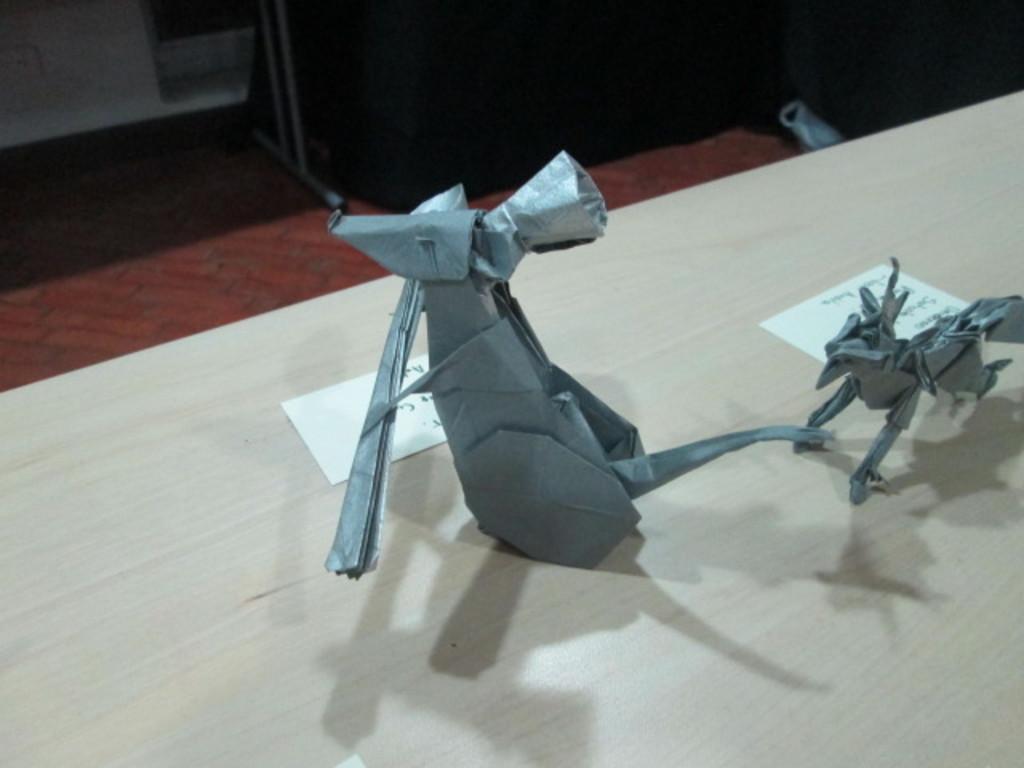Describe this image in one or two sentences. In this image, I can see two paper toys and two pieces of papers are placed on the table. This looks like a floor. At the top of the image, I can see another object, which is black in color. 